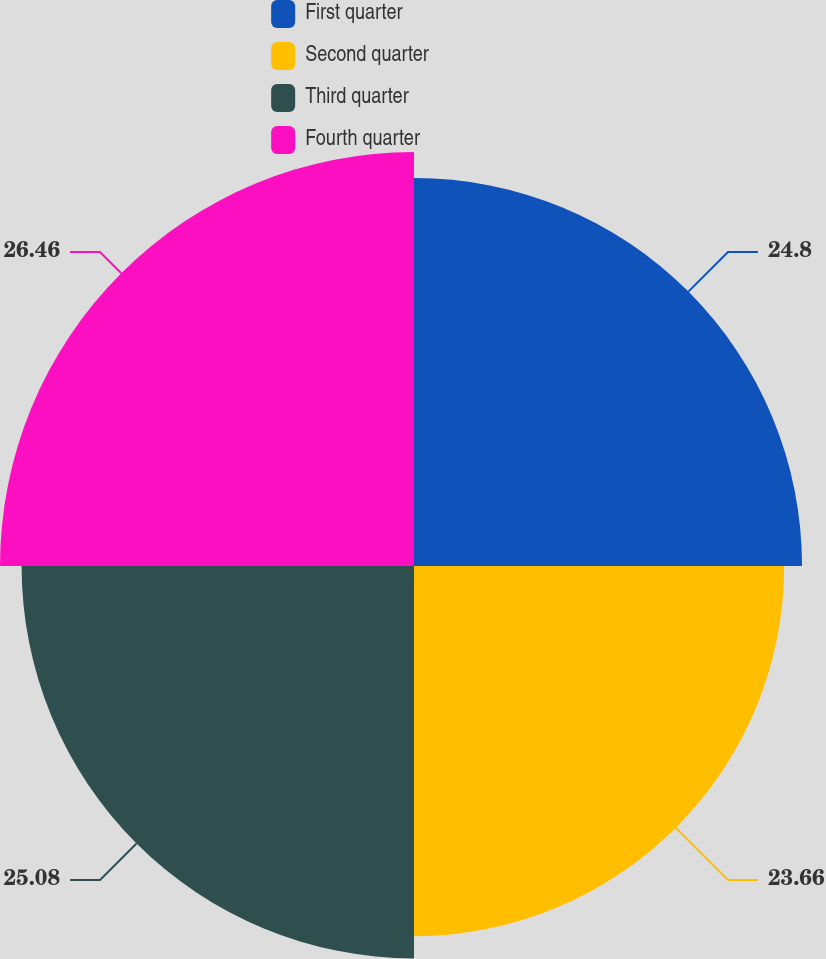Convert chart. <chart><loc_0><loc_0><loc_500><loc_500><pie_chart><fcel>First quarter<fcel>Second quarter<fcel>Third quarter<fcel>Fourth quarter<nl><fcel>24.8%<fcel>23.66%<fcel>25.08%<fcel>26.46%<nl></chart> 